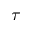Convert formula to latex. <formula><loc_0><loc_0><loc_500><loc_500>\tau</formula> 